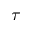Convert formula to latex. <formula><loc_0><loc_0><loc_500><loc_500>\tau</formula> 